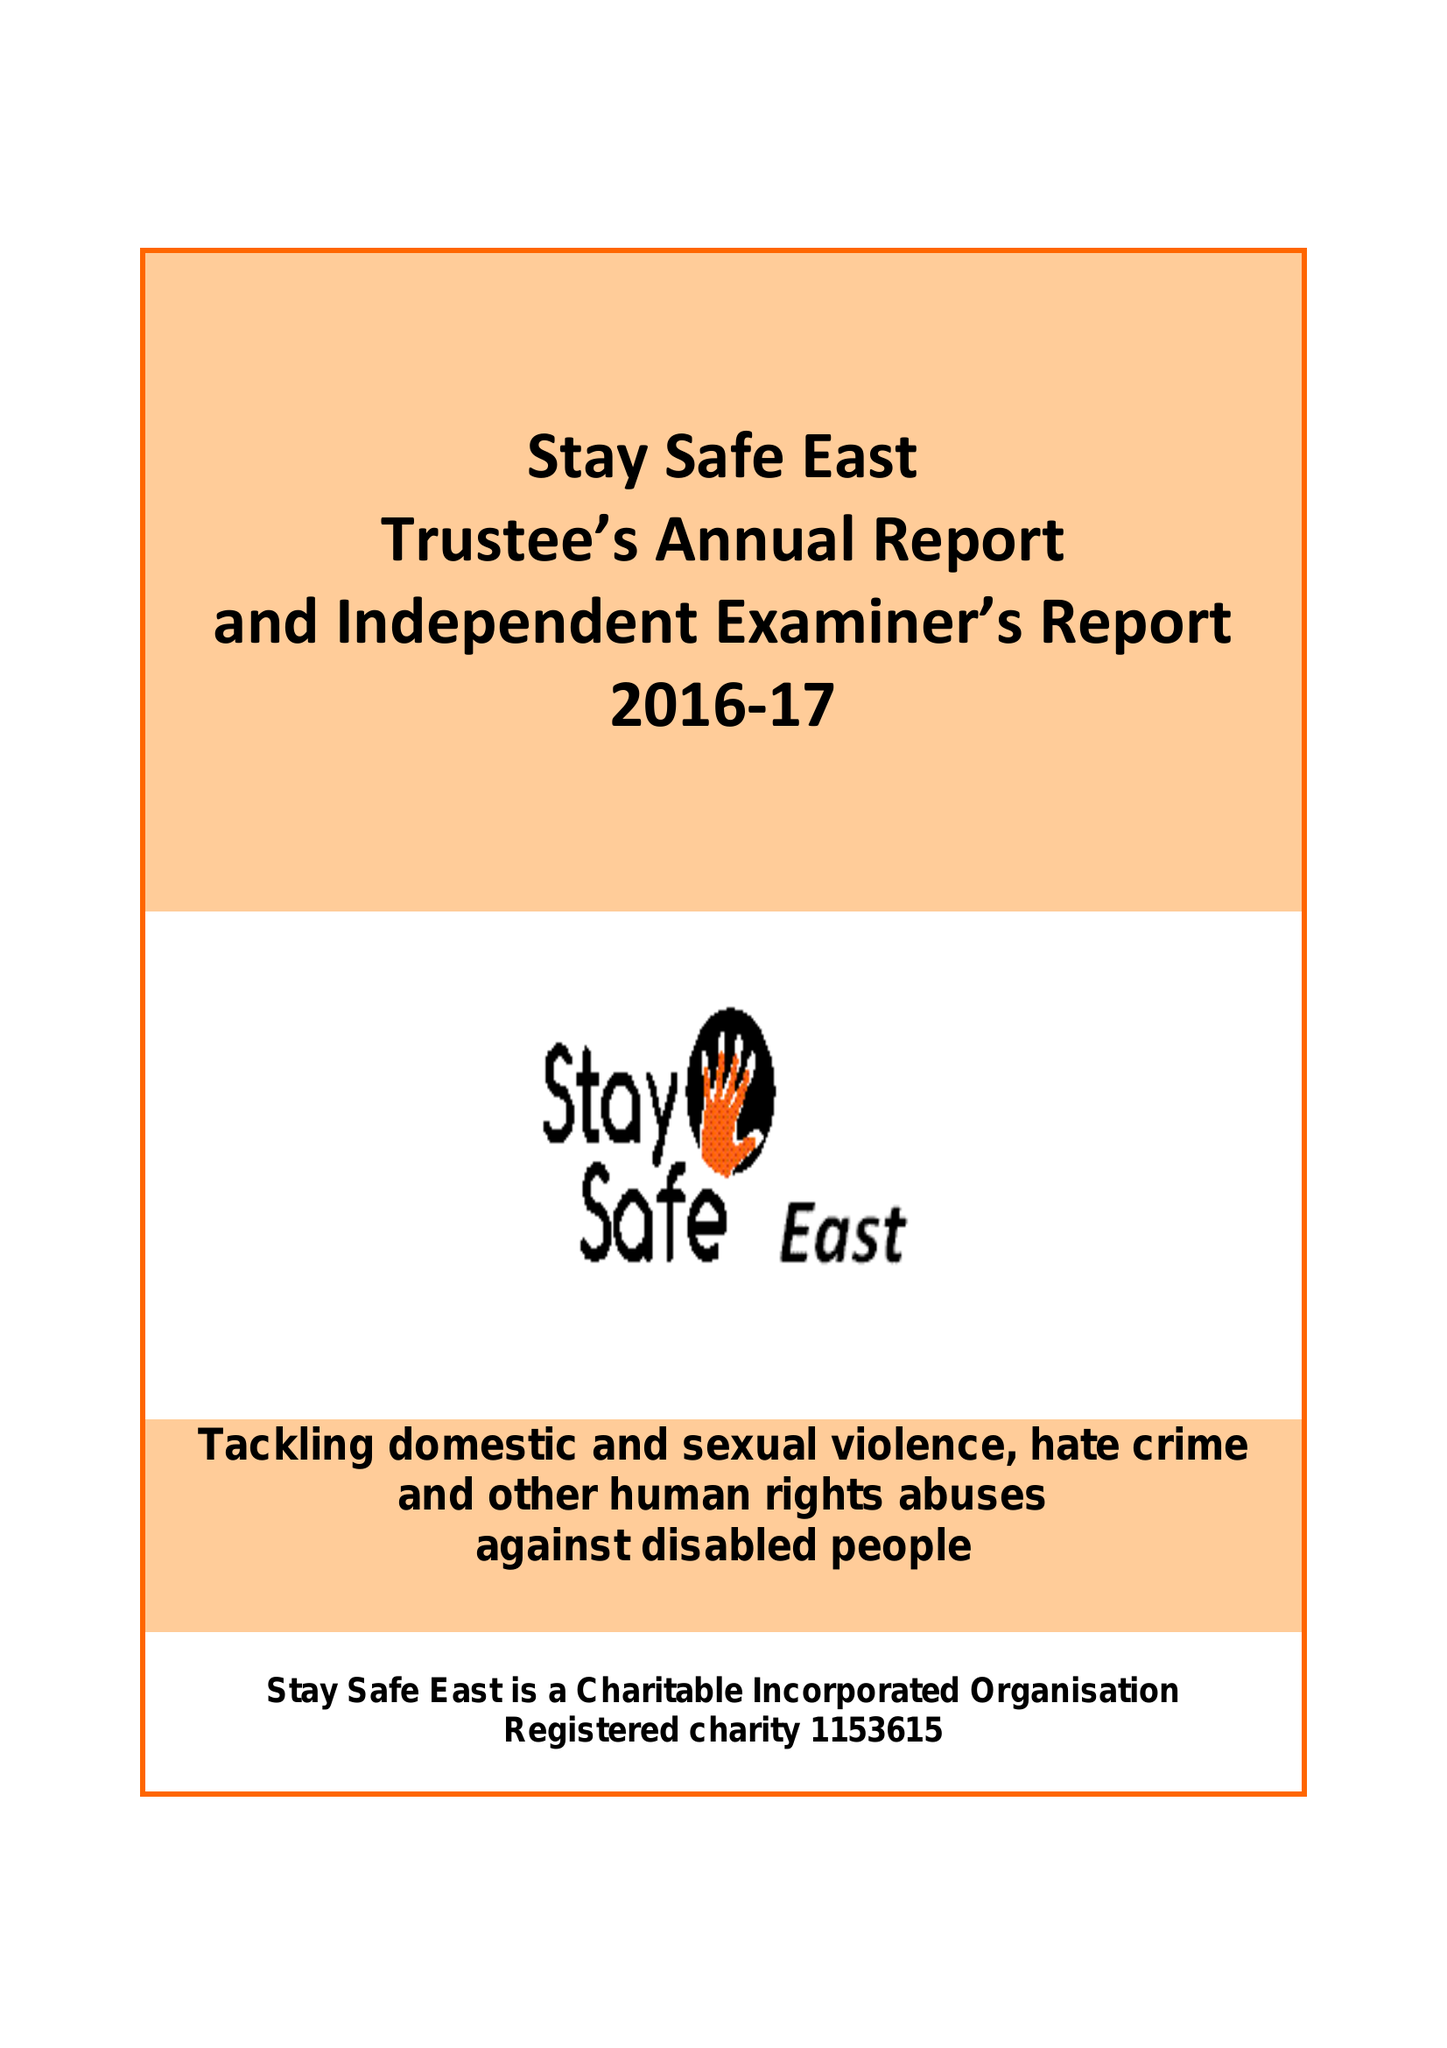What is the value for the spending_annually_in_british_pounds?
Answer the question using a single word or phrase. 104325.00 